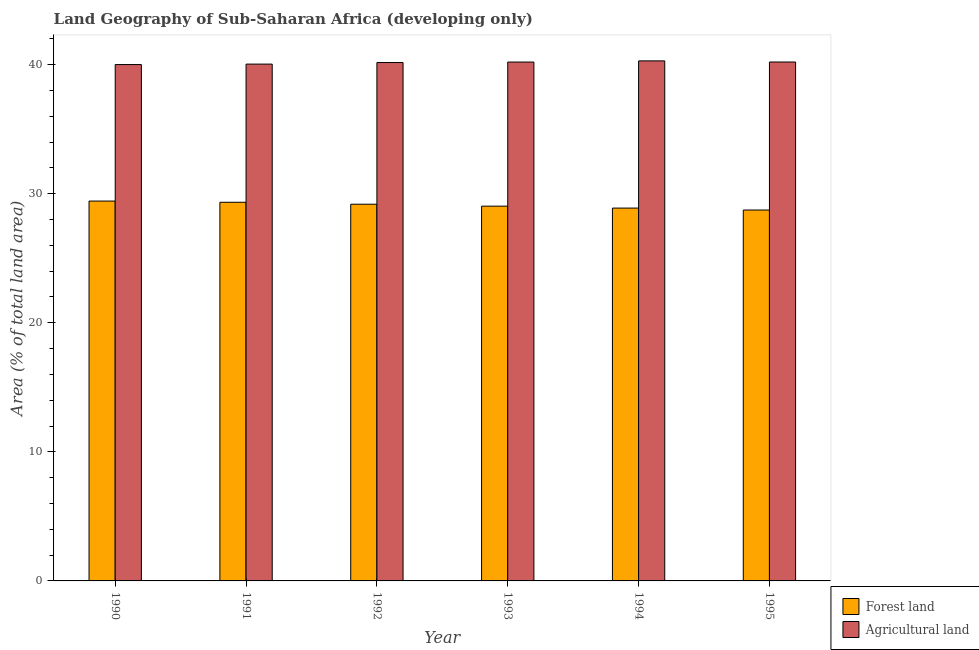How many different coloured bars are there?
Your response must be concise. 2. Are the number of bars per tick equal to the number of legend labels?
Keep it short and to the point. Yes. Are the number of bars on each tick of the X-axis equal?
Keep it short and to the point. Yes. How many bars are there on the 3rd tick from the left?
Make the answer very short. 2. How many bars are there on the 4th tick from the right?
Your answer should be very brief. 2. What is the percentage of land area under agriculture in 1991?
Offer a very short reply. 40.04. Across all years, what is the maximum percentage of land area under agriculture?
Your answer should be very brief. 40.29. Across all years, what is the minimum percentage of land area under agriculture?
Ensure brevity in your answer.  40. In which year was the percentage of land area under forests minimum?
Make the answer very short. 1995. What is the total percentage of land area under forests in the graph?
Provide a succinct answer. 174.6. What is the difference between the percentage of land area under forests in 1992 and that in 1993?
Provide a succinct answer. 0.15. What is the difference between the percentage of land area under agriculture in 1990 and the percentage of land area under forests in 1995?
Offer a very short reply. -0.2. What is the average percentage of land area under forests per year?
Your response must be concise. 29.1. What is the ratio of the percentage of land area under agriculture in 1993 to that in 1995?
Give a very brief answer. 1. Is the difference between the percentage of land area under forests in 1993 and 1994 greater than the difference between the percentage of land area under agriculture in 1993 and 1994?
Your answer should be compact. No. What is the difference between the highest and the second highest percentage of land area under forests?
Offer a terse response. 0.09. What is the difference between the highest and the lowest percentage of land area under forests?
Offer a terse response. 0.69. What does the 2nd bar from the left in 1992 represents?
Provide a short and direct response. Agricultural land. What does the 1st bar from the right in 1992 represents?
Offer a terse response. Agricultural land. Are all the bars in the graph horizontal?
Your answer should be very brief. No. How many years are there in the graph?
Offer a terse response. 6. What is the difference between two consecutive major ticks on the Y-axis?
Make the answer very short. 10. Are the values on the major ticks of Y-axis written in scientific E-notation?
Keep it short and to the point. No. Does the graph contain any zero values?
Your response must be concise. No. Does the graph contain grids?
Offer a very short reply. No. How many legend labels are there?
Your response must be concise. 2. What is the title of the graph?
Your response must be concise. Land Geography of Sub-Saharan Africa (developing only). Does "Automatic Teller Machines" appear as one of the legend labels in the graph?
Give a very brief answer. No. What is the label or title of the Y-axis?
Offer a very short reply. Area (% of total land area). What is the Area (% of total land area) of Forest land in 1990?
Offer a terse response. 29.43. What is the Area (% of total land area) of Agricultural land in 1990?
Your response must be concise. 40. What is the Area (% of total land area) in Forest land in 1991?
Provide a short and direct response. 29.33. What is the Area (% of total land area) in Agricultural land in 1991?
Give a very brief answer. 40.04. What is the Area (% of total land area) in Forest land in 1992?
Give a very brief answer. 29.18. What is the Area (% of total land area) in Agricultural land in 1992?
Provide a short and direct response. 40.16. What is the Area (% of total land area) in Forest land in 1993?
Your answer should be very brief. 29.03. What is the Area (% of total land area) in Agricultural land in 1993?
Offer a terse response. 40.2. What is the Area (% of total land area) of Forest land in 1994?
Give a very brief answer. 28.88. What is the Area (% of total land area) of Agricultural land in 1994?
Make the answer very short. 40.29. What is the Area (% of total land area) in Forest land in 1995?
Offer a very short reply. 28.73. What is the Area (% of total land area) in Agricultural land in 1995?
Offer a terse response. 40.2. Across all years, what is the maximum Area (% of total land area) in Forest land?
Keep it short and to the point. 29.43. Across all years, what is the maximum Area (% of total land area) in Agricultural land?
Keep it short and to the point. 40.29. Across all years, what is the minimum Area (% of total land area) of Forest land?
Provide a succinct answer. 28.73. Across all years, what is the minimum Area (% of total land area) of Agricultural land?
Offer a terse response. 40. What is the total Area (% of total land area) in Forest land in the graph?
Your answer should be very brief. 174.6. What is the total Area (% of total land area) of Agricultural land in the graph?
Your answer should be very brief. 240.89. What is the difference between the Area (% of total land area) of Forest land in 1990 and that in 1991?
Ensure brevity in your answer.  0.09. What is the difference between the Area (% of total land area) in Agricultural land in 1990 and that in 1991?
Your response must be concise. -0.03. What is the difference between the Area (% of total land area) of Forest land in 1990 and that in 1992?
Provide a short and direct response. 0.24. What is the difference between the Area (% of total land area) in Agricultural land in 1990 and that in 1992?
Ensure brevity in your answer.  -0.16. What is the difference between the Area (% of total land area) in Forest land in 1990 and that in 1993?
Give a very brief answer. 0.39. What is the difference between the Area (% of total land area) in Agricultural land in 1990 and that in 1993?
Provide a succinct answer. -0.19. What is the difference between the Area (% of total land area) in Forest land in 1990 and that in 1994?
Your answer should be very brief. 0.54. What is the difference between the Area (% of total land area) of Agricultural land in 1990 and that in 1994?
Provide a short and direct response. -0.28. What is the difference between the Area (% of total land area) in Forest land in 1990 and that in 1995?
Make the answer very short. 0.69. What is the difference between the Area (% of total land area) in Agricultural land in 1990 and that in 1995?
Make the answer very short. -0.2. What is the difference between the Area (% of total land area) in Forest land in 1991 and that in 1992?
Make the answer very short. 0.15. What is the difference between the Area (% of total land area) in Agricultural land in 1991 and that in 1992?
Your answer should be compact. -0.12. What is the difference between the Area (% of total land area) of Forest land in 1991 and that in 1993?
Your answer should be compact. 0.3. What is the difference between the Area (% of total land area) in Agricultural land in 1991 and that in 1993?
Provide a succinct answer. -0.16. What is the difference between the Area (% of total land area) in Forest land in 1991 and that in 1994?
Your answer should be very brief. 0.45. What is the difference between the Area (% of total land area) in Agricultural land in 1991 and that in 1994?
Your answer should be very brief. -0.25. What is the difference between the Area (% of total land area) of Forest land in 1991 and that in 1995?
Provide a short and direct response. 0.6. What is the difference between the Area (% of total land area) in Agricultural land in 1991 and that in 1995?
Ensure brevity in your answer.  -0.16. What is the difference between the Area (% of total land area) in Forest land in 1992 and that in 1993?
Keep it short and to the point. 0.15. What is the difference between the Area (% of total land area) in Agricultural land in 1992 and that in 1993?
Ensure brevity in your answer.  -0.04. What is the difference between the Area (% of total land area) in Forest land in 1992 and that in 1994?
Give a very brief answer. 0.3. What is the difference between the Area (% of total land area) of Agricultural land in 1992 and that in 1994?
Your answer should be compact. -0.13. What is the difference between the Area (% of total land area) in Forest land in 1992 and that in 1995?
Give a very brief answer. 0.45. What is the difference between the Area (% of total land area) in Agricultural land in 1992 and that in 1995?
Your answer should be compact. -0.04. What is the difference between the Area (% of total land area) in Forest land in 1993 and that in 1994?
Make the answer very short. 0.15. What is the difference between the Area (% of total land area) of Agricultural land in 1993 and that in 1994?
Your response must be concise. -0.09. What is the difference between the Area (% of total land area) in Forest land in 1993 and that in 1995?
Ensure brevity in your answer.  0.3. What is the difference between the Area (% of total land area) in Agricultural land in 1993 and that in 1995?
Your answer should be very brief. -0. What is the difference between the Area (% of total land area) of Forest land in 1994 and that in 1995?
Provide a succinct answer. 0.15. What is the difference between the Area (% of total land area) in Agricultural land in 1994 and that in 1995?
Your response must be concise. 0.09. What is the difference between the Area (% of total land area) in Forest land in 1990 and the Area (% of total land area) in Agricultural land in 1991?
Offer a terse response. -10.61. What is the difference between the Area (% of total land area) of Forest land in 1990 and the Area (% of total land area) of Agricultural land in 1992?
Provide a short and direct response. -10.73. What is the difference between the Area (% of total land area) in Forest land in 1990 and the Area (% of total land area) in Agricultural land in 1993?
Give a very brief answer. -10.77. What is the difference between the Area (% of total land area) of Forest land in 1990 and the Area (% of total land area) of Agricultural land in 1994?
Give a very brief answer. -10.86. What is the difference between the Area (% of total land area) of Forest land in 1990 and the Area (% of total land area) of Agricultural land in 1995?
Provide a short and direct response. -10.77. What is the difference between the Area (% of total land area) in Forest land in 1991 and the Area (% of total land area) in Agricultural land in 1992?
Offer a terse response. -10.82. What is the difference between the Area (% of total land area) in Forest land in 1991 and the Area (% of total land area) in Agricultural land in 1993?
Provide a short and direct response. -10.86. What is the difference between the Area (% of total land area) in Forest land in 1991 and the Area (% of total land area) in Agricultural land in 1994?
Your answer should be compact. -10.95. What is the difference between the Area (% of total land area) in Forest land in 1991 and the Area (% of total land area) in Agricultural land in 1995?
Provide a succinct answer. -10.87. What is the difference between the Area (% of total land area) of Forest land in 1992 and the Area (% of total land area) of Agricultural land in 1993?
Offer a terse response. -11.01. What is the difference between the Area (% of total land area) in Forest land in 1992 and the Area (% of total land area) in Agricultural land in 1994?
Offer a terse response. -11.1. What is the difference between the Area (% of total land area) in Forest land in 1992 and the Area (% of total land area) in Agricultural land in 1995?
Give a very brief answer. -11.02. What is the difference between the Area (% of total land area) of Forest land in 1993 and the Area (% of total land area) of Agricultural land in 1994?
Offer a very short reply. -11.25. What is the difference between the Area (% of total land area) of Forest land in 1993 and the Area (% of total land area) of Agricultural land in 1995?
Your answer should be compact. -11.17. What is the difference between the Area (% of total land area) of Forest land in 1994 and the Area (% of total land area) of Agricultural land in 1995?
Keep it short and to the point. -11.32. What is the average Area (% of total land area) in Forest land per year?
Offer a very short reply. 29.1. What is the average Area (% of total land area) of Agricultural land per year?
Provide a succinct answer. 40.15. In the year 1990, what is the difference between the Area (% of total land area) in Forest land and Area (% of total land area) in Agricultural land?
Offer a very short reply. -10.58. In the year 1991, what is the difference between the Area (% of total land area) of Forest land and Area (% of total land area) of Agricultural land?
Give a very brief answer. -10.7. In the year 1992, what is the difference between the Area (% of total land area) of Forest land and Area (% of total land area) of Agricultural land?
Provide a succinct answer. -10.97. In the year 1993, what is the difference between the Area (% of total land area) of Forest land and Area (% of total land area) of Agricultural land?
Offer a very short reply. -11.16. In the year 1994, what is the difference between the Area (% of total land area) of Forest land and Area (% of total land area) of Agricultural land?
Ensure brevity in your answer.  -11.4. In the year 1995, what is the difference between the Area (% of total land area) of Forest land and Area (% of total land area) of Agricultural land?
Ensure brevity in your answer.  -11.47. What is the ratio of the Area (% of total land area) in Agricultural land in 1990 to that in 1991?
Your answer should be very brief. 1. What is the ratio of the Area (% of total land area) in Forest land in 1990 to that in 1992?
Your answer should be very brief. 1.01. What is the ratio of the Area (% of total land area) in Agricultural land in 1990 to that in 1992?
Ensure brevity in your answer.  1. What is the ratio of the Area (% of total land area) in Forest land in 1990 to that in 1993?
Offer a very short reply. 1.01. What is the ratio of the Area (% of total land area) in Agricultural land in 1990 to that in 1993?
Your answer should be compact. 1. What is the ratio of the Area (% of total land area) in Forest land in 1990 to that in 1994?
Give a very brief answer. 1.02. What is the ratio of the Area (% of total land area) of Forest land in 1990 to that in 1995?
Offer a very short reply. 1.02. What is the ratio of the Area (% of total land area) in Agricultural land in 1990 to that in 1995?
Ensure brevity in your answer.  1. What is the ratio of the Area (% of total land area) of Forest land in 1991 to that in 1993?
Your response must be concise. 1.01. What is the ratio of the Area (% of total land area) of Forest land in 1991 to that in 1994?
Your response must be concise. 1.02. What is the ratio of the Area (% of total land area) of Agricultural land in 1991 to that in 1994?
Ensure brevity in your answer.  0.99. What is the ratio of the Area (% of total land area) of Forest land in 1991 to that in 1995?
Make the answer very short. 1.02. What is the ratio of the Area (% of total land area) of Forest land in 1992 to that in 1994?
Keep it short and to the point. 1.01. What is the ratio of the Area (% of total land area) in Agricultural land in 1992 to that in 1994?
Ensure brevity in your answer.  1. What is the ratio of the Area (% of total land area) of Forest land in 1992 to that in 1995?
Your response must be concise. 1.02. What is the ratio of the Area (% of total land area) of Agricultural land in 1992 to that in 1995?
Your response must be concise. 1. What is the ratio of the Area (% of total land area) of Agricultural land in 1993 to that in 1994?
Offer a very short reply. 1. What is the ratio of the Area (% of total land area) of Forest land in 1993 to that in 1995?
Provide a succinct answer. 1.01. What is the ratio of the Area (% of total land area) in Agricultural land in 1993 to that in 1995?
Your answer should be compact. 1. What is the ratio of the Area (% of total land area) of Forest land in 1994 to that in 1995?
Make the answer very short. 1.01. What is the difference between the highest and the second highest Area (% of total land area) of Forest land?
Your response must be concise. 0.09. What is the difference between the highest and the second highest Area (% of total land area) of Agricultural land?
Make the answer very short. 0.09. What is the difference between the highest and the lowest Area (% of total land area) of Forest land?
Offer a very short reply. 0.69. What is the difference between the highest and the lowest Area (% of total land area) of Agricultural land?
Give a very brief answer. 0.28. 